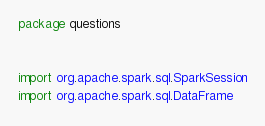Convert code to text. <code><loc_0><loc_0><loc_500><loc_500><_Scala_>package questions


import org.apache.spark.sql.SparkSession
import org.apache.spark.sql.DataFrame</code> 